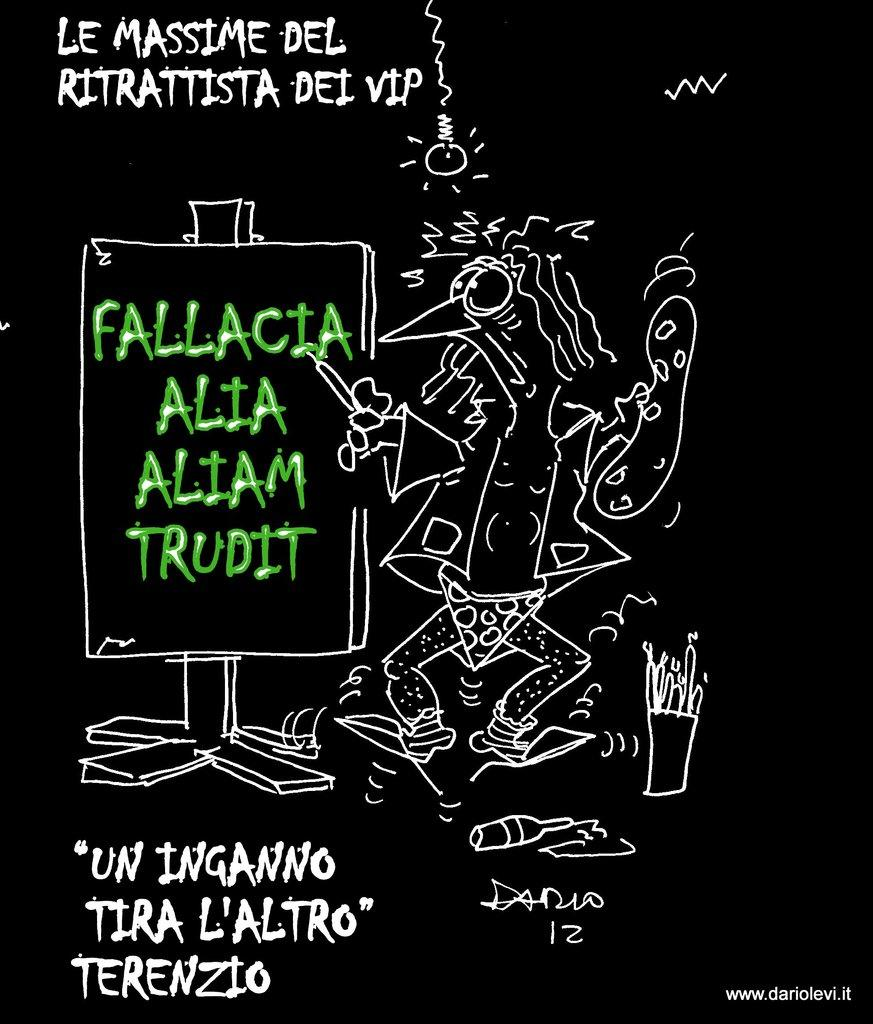<image>
Relay a brief, clear account of the picture shown. A black poster with art in white by Dario. 